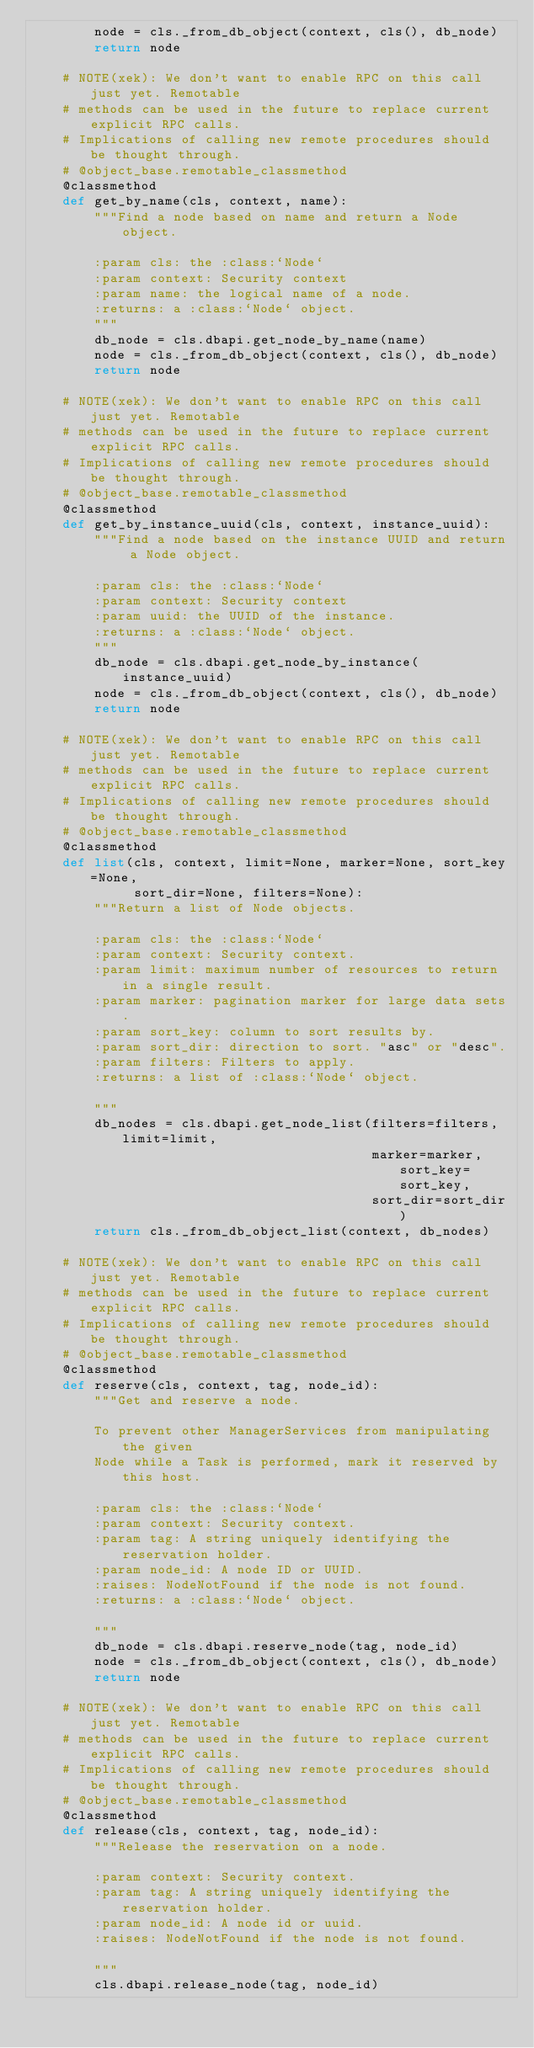Convert code to text. <code><loc_0><loc_0><loc_500><loc_500><_Python_>        node = cls._from_db_object(context, cls(), db_node)
        return node

    # NOTE(xek): We don't want to enable RPC on this call just yet. Remotable
    # methods can be used in the future to replace current explicit RPC calls.
    # Implications of calling new remote procedures should be thought through.
    # @object_base.remotable_classmethod
    @classmethod
    def get_by_name(cls, context, name):
        """Find a node based on name and return a Node object.

        :param cls: the :class:`Node`
        :param context: Security context
        :param name: the logical name of a node.
        :returns: a :class:`Node` object.
        """
        db_node = cls.dbapi.get_node_by_name(name)
        node = cls._from_db_object(context, cls(), db_node)
        return node

    # NOTE(xek): We don't want to enable RPC on this call just yet. Remotable
    # methods can be used in the future to replace current explicit RPC calls.
    # Implications of calling new remote procedures should be thought through.
    # @object_base.remotable_classmethod
    @classmethod
    def get_by_instance_uuid(cls, context, instance_uuid):
        """Find a node based on the instance UUID and return a Node object.

        :param cls: the :class:`Node`
        :param context: Security context
        :param uuid: the UUID of the instance.
        :returns: a :class:`Node` object.
        """
        db_node = cls.dbapi.get_node_by_instance(instance_uuid)
        node = cls._from_db_object(context, cls(), db_node)
        return node

    # NOTE(xek): We don't want to enable RPC on this call just yet. Remotable
    # methods can be used in the future to replace current explicit RPC calls.
    # Implications of calling new remote procedures should be thought through.
    # @object_base.remotable_classmethod
    @classmethod
    def list(cls, context, limit=None, marker=None, sort_key=None,
             sort_dir=None, filters=None):
        """Return a list of Node objects.

        :param cls: the :class:`Node`
        :param context: Security context.
        :param limit: maximum number of resources to return in a single result.
        :param marker: pagination marker for large data sets.
        :param sort_key: column to sort results by.
        :param sort_dir: direction to sort. "asc" or "desc".
        :param filters: Filters to apply.
        :returns: a list of :class:`Node` object.

        """
        db_nodes = cls.dbapi.get_node_list(filters=filters, limit=limit,
                                           marker=marker, sort_key=sort_key,
                                           sort_dir=sort_dir)
        return cls._from_db_object_list(context, db_nodes)

    # NOTE(xek): We don't want to enable RPC on this call just yet. Remotable
    # methods can be used in the future to replace current explicit RPC calls.
    # Implications of calling new remote procedures should be thought through.
    # @object_base.remotable_classmethod
    @classmethod
    def reserve(cls, context, tag, node_id):
        """Get and reserve a node.

        To prevent other ManagerServices from manipulating the given
        Node while a Task is performed, mark it reserved by this host.

        :param cls: the :class:`Node`
        :param context: Security context.
        :param tag: A string uniquely identifying the reservation holder.
        :param node_id: A node ID or UUID.
        :raises: NodeNotFound if the node is not found.
        :returns: a :class:`Node` object.

        """
        db_node = cls.dbapi.reserve_node(tag, node_id)
        node = cls._from_db_object(context, cls(), db_node)
        return node

    # NOTE(xek): We don't want to enable RPC on this call just yet. Remotable
    # methods can be used in the future to replace current explicit RPC calls.
    # Implications of calling new remote procedures should be thought through.
    # @object_base.remotable_classmethod
    @classmethod
    def release(cls, context, tag, node_id):
        """Release the reservation on a node.

        :param context: Security context.
        :param tag: A string uniquely identifying the reservation holder.
        :param node_id: A node id or uuid.
        :raises: NodeNotFound if the node is not found.

        """
        cls.dbapi.release_node(tag, node_id)
</code> 